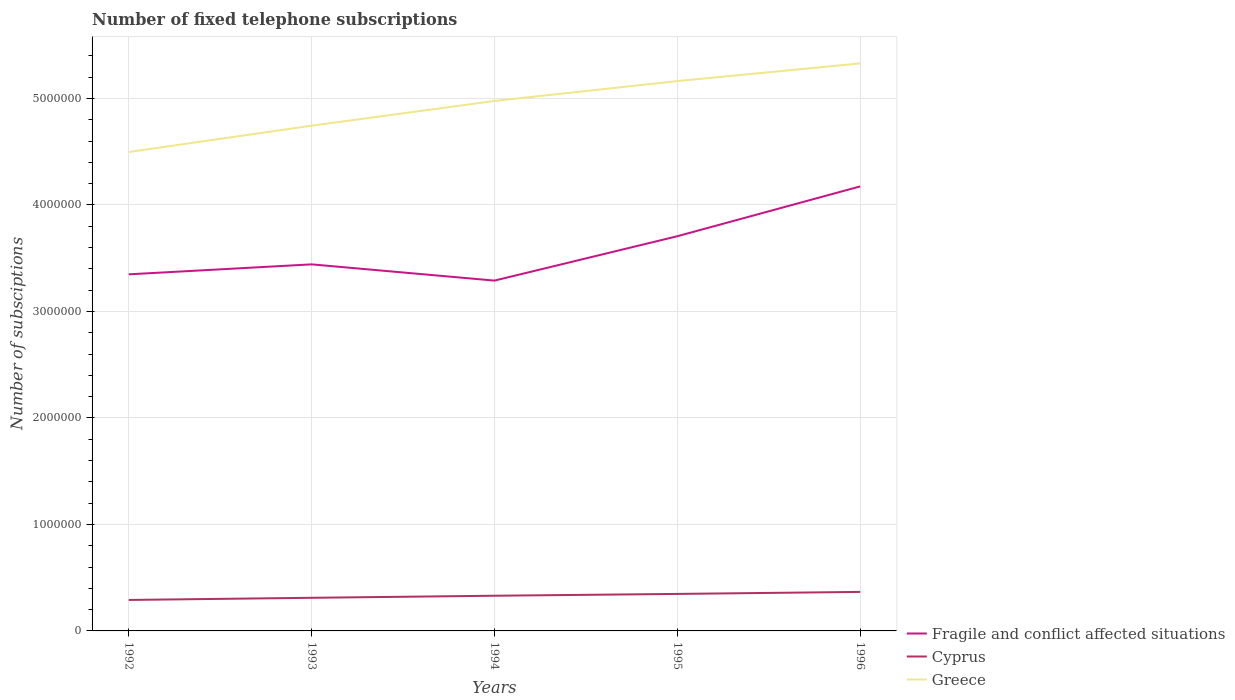How many different coloured lines are there?
Keep it short and to the point. 3. Across all years, what is the maximum number of fixed telephone subscriptions in Greece?
Keep it short and to the point. 4.50e+06. What is the total number of fixed telephone subscriptions in Fragile and conflict affected situations in the graph?
Keep it short and to the point. -9.36e+04. What is the difference between the highest and the second highest number of fixed telephone subscriptions in Cyprus?
Keep it short and to the point. 7.55e+04. Is the number of fixed telephone subscriptions in Fragile and conflict affected situations strictly greater than the number of fixed telephone subscriptions in Cyprus over the years?
Give a very brief answer. No. How many lines are there?
Ensure brevity in your answer.  3. What is the difference between two consecutive major ticks on the Y-axis?
Offer a terse response. 1.00e+06. What is the title of the graph?
Make the answer very short. Number of fixed telephone subscriptions. Does "Burundi" appear as one of the legend labels in the graph?
Offer a terse response. No. What is the label or title of the X-axis?
Provide a short and direct response. Years. What is the label or title of the Y-axis?
Your response must be concise. Number of subsciptions. What is the Number of subsciptions in Fragile and conflict affected situations in 1992?
Your answer should be very brief. 3.35e+06. What is the Number of subsciptions of Cyprus in 1992?
Offer a terse response. 2.91e+05. What is the Number of subsciptions in Greece in 1992?
Give a very brief answer. 4.50e+06. What is the Number of subsciptions in Fragile and conflict affected situations in 1993?
Offer a very short reply. 3.44e+06. What is the Number of subsciptions in Cyprus in 1993?
Make the answer very short. 3.11e+05. What is the Number of subsciptions in Greece in 1993?
Your answer should be compact. 4.74e+06. What is the Number of subsciptions in Fragile and conflict affected situations in 1994?
Make the answer very short. 3.29e+06. What is the Number of subsciptions of Cyprus in 1994?
Make the answer very short. 3.30e+05. What is the Number of subsciptions in Greece in 1994?
Keep it short and to the point. 4.98e+06. What is the Number of subsciptions of Fragile and conflict affected situations in 1995?
Provide a succinct answer. 3.71e+06. What is the Number of subsciptions in Cyprus in 1995?
Keep it short and to the point. 3.47e+05. What is the Number of subsciptions of Greece in 1995?
Give a very brief answer. 5.16e+06. What is the Number of subsciptions in Fragile and conflict affected situations in 1996?
Your answer should be compact. 4.17e+06. What is the Number of subsciptions of Cyprus in 1996?
Give a very brief answer. 3.66e+05. What is the Number of subsciptions of Greece in 1996?
Your response must be concise. 5.33e+06. Across all years, what is the maximum Number of subsciptions in Fragile and conflict affected situations?
Keep it short and to the point. 4.17e+06. Across all years, what is the maximum Number of subsciptions of Cyprus?
Ensure brevity in your answer.  3.66e+05. Across all years, what is the maximum Number of subsciptions in Greece?
Give a very brief answer. 5.33e+06. Across all years, what is the minimum Number of subsciptions of Fragile and conflict affected situations?
Ensure brevity in your answer.  3.29e+06. Across all years, what is the minimum Number of subsciptions in Cyprus?
Provide a short and direct response. 2.91e+05. Across all years, what is the minimum Number of subsciptions of Greece?
Your answer should be compact. 4.50e+06. What is the total Number of subsciptions in Fragile and conflict affected situations in the graph?
Provide a succinct answer. 1.80e+07. What is the total Number of subsciptions in Cyprus in the graph?
Your response must be concise. 1.65e+06. What is the total Number of subsciptions of Greece in the graph?
Your answer should be compact. 2.47e+07. What is the difference between the Number of subsciptions of Fragile and conflict affected situations in 1992 and that in 1993?
Make the answer very short. -9.36e+04. What is the difference between the Number of subsciptions of Cyprus in 1992 and that in 1993?
Offer a very short reply. -2.01e+04. What is the difference between the Number of subsciptions of Greece in 1992 and that in 1993?
Offer a very short reply. -2.47e+05. What is the difference between the Number of subsciptions of Fragile and conflict affected situations in 1992 and that in 1994?
Make the answer very short. 5.88e+04. What is the difference between the Number of subsciptions of Cyprus in 1992 and that in 1994?
Provide a short and direct response. -3.95e+04. What is the difference between the Number of subsciptions of Greece in 1992 and that in 1994?
Your answer should be compact. -4.80e+05. What is the difference between the Number of subsciptions of Fragile and conflict affected situations in 1992 and that in 1995?
Provide a short and direct response. -3.58e+05. What is the difference between the Number of subsciptions of Cyprus in 1992 and that in 1995?
Give a very brief answer. -5.65e+04. What is the difference between the Number of subsciptions in Greece in 1992 and that in 1995?
Provide a succinct answer. -6.66e+05. What is the difference between the Number of subsciptions in Fragile and conflict affected situations in 1992 and that in 1996?
Your response must be concise. -8.26e+05. What is the difference between the Number of subsciptions of Cyprus in 1992 and that in 1996?
Offer a very short reply. -7.55e+04. What is the difference between the Number of subsciptions in Greece in 1992 and that in 1996?
Make the answer very short. -8.32e+05. What is the difference between the Number of subsciptions in Fragile and conflict affected situations in 1993 and that in 1994?
Keep it short and to the point. 1.52e+05. What is the difference between the Number of subsciptions in Cyprus in 1993 and that in 1994?
Provide a short and direct response. -1.94e+04. What is the difference between the Number of subsciptions of Greece in 1993 and that in 1994?
Your answer should be very brief. -2.32e+05. What is the difference between the Number of subsciptions in Fragile and conflict affected situations in 1993 and that in 1995?
Make the answer very short. -2.64e+05. What is the difference between the Number of subsciptions in Cyprus in 1993 and that in 1995?
Give a very brief answer. -3.64e+04. What is the difference between the Number of subsciptions of Greece in 1993 and that in 1995?
Ensure brevity in your answer.  -4.19e+05. What is the difference between the Number of subsciptions in Fragile and conflict affected situations in 1993 and that in 1996?
Provide a succinct answer. -7.32e+05. What is the difference between the Number of subsciptions in Cyprus in 1993 and that in 1996?
Your answer should be very brief. -5.54e+04. What is the difference between the Number of subsciptions of Greece in 1993 and that in 1996?
Give a very brief answer. -5.85e+05. What is the difference between the Number of subsciptions in Fragile and conflict affected situations in 1994 and that in 1995?
Provide a short and direct response. -4.17e+05. What is the difference between the Number of subsciptions of Cyprus in 1994 and that in 1995?
Ensure brevity in your answer.  -1.70e+04. What is the difference between the Number of subsciptions of Greece in 1994 and that in 1995?
Keep it short and to the point. -1.87e+05. What is the difference between the Number of subsciptions of Fragile and conflict affected situations in 1994 and that in 1996?
Give a very brief answer. -8.85e+05. What is the difference between the Number of subsciptions of Cyprus in 1994 and that in 1996?
Offer a very short reply. -3.60e+04. What is the difference between the Number of subsciptions in Greece in 1994 and that in 1996?
Provide a short and direct response. -3.53e+05. What is the difference between the Number of subsciptions in Fragile and conflict affected situations in 1995 and that in 1996?
Ensure brevity in your answer.  -4.68e+05. What is the difference between the Number of subsciptions in Cyprus in 1995 and that in 1996?
Your answer should be compact. -1.90e+04. What is the difference between the Number of subsciptions of Greece in 1995 and that in 1996?
Give a very brief answer. -1.66e+05. What is the difference between the Number of subsciptions of Fragile and conflict affected situations in 1992 and the Number of subsciptions of Cyprus in 1993?
Provide a succinct answer. 3.04e+06. What is the difference between the Number of subsciptions of Fragile and conflict affected situations in 1992 and the Number of subsciptions of Greece in 1993?
Offer a terse response. -1.40e+06. What is the difference between the Number of subsciptions of Cyprus in 1992 and the Number of subsciptions of Greece in 1993?
Offer a very short reply. -4.45e+06. What is the difference between the Number of subsciptions in Fragile and conflict affected situations in 1992 and the Number of subsciptions in Cyprus in 1994?
Ensure brevity in your answer.  3.02e+06. What is the difference between the Number of subsciptions in Fragile and conflict affected situations in 1992 and the Number of subsciptions in Greece in 1994?
Provide a short and direct response. -1.63e+06. What is the difference between the Number of subsciptions of Cyprus in 1992 and the Number of subsciptions of Greece in 1994?
Your response must be concise. -4.69e+06. What is the difference between the Number of subsciptions of Fragile and conflict affected situations in 1992 and the Number of subsciptions of Cyprus in 1995?
Give a very brief answer. 3.00e+06. What is the difference between the Number of subsciptions of Fragile and conflict affected situations in 1992 and the Number of subsciptions of Greece in 1995?
Offer a very short reply. -1.81e+06. What is the difference between the Number of subsciptions in Cyprus in 1992 and the Number of subsciptions in Greece in 1995?
Provide a succinct answer. -4.87e+06. What is the difference between the Number of subsciptions in Fragile and conflict affected situations in 1992 and the Number of subsciptions in Cyprus in 1996?
Give a very brief answer. 2.98e+06. What is the difference between the Number of subsciptions of Fragile and conflict affected situations in 1992 and the Number of subsciptions of Greece in 1996?
Give a very brief answer. -1.98e+06. What is the difference between the Number of subsciptions in Cyprus in 1992 and the Number of subsciptions in Greece in 1996?
Provide a succinct answer. -5.04e+06. What is the difference between the Number of subsciptions in Fragile and conflict affected situations in 1993 and the Number of subsciptions in Cyprus in 1994?
Your response must be concise. 3.11e+06. What is the difference between the Number of subsciptions of Fragile and conflict affected situations in 1993 and the Number of subsciptions of Greece in 1994?
Make the answer very short. -1.53e+06. What is the difference between the Number of subsciptions in Cyprus in 1993 and the Number of subsciptions in Greece in 1994?
Offer a terse response. -4.67e+06. What is the difference between the Number of subsciptions in Fragile and conflict affected situations in 1993 and the Number of subsciptions in Cyprus in 1995?
Ensure brevity in your answer.  3.09e+06. What is the difference between the Number of subsciptions of Fragile and conflict affected situations in 1993 and the Number of subsciptions of Greece in 1995?
Your answer should be very brief. -1.72e+06. What is the difference between the Number of subsciptions in Cyprus in 1993 and the Number of subsciptions in Greece in 1995?
Your answer should be very brief. -4.85e+06. What is the difference between the Number of subsciptions of Fragile and conflict affected situations in 1993 and the Number of subsciptions of Cyprus in 1996?
Your answer should be compact. 3.08e+06. What is the difference between the Number of subsciptions of Fragile and conflict affected situations in 1993 and the Number of subsciptions of Greece in 1996?
Ensure brevity in your answer.  -1.89e+06. What is the difference between the Number of subsciptions in Cyprus in 1993 and the Number of subsciptions in Greece in 1996?
Ensure brevity in your answer.  -5.02e+06. What is the difference between the Number of subsciptions in Fragile and conflict affected situations in 1994 and the Number of subsciptions in Cyprus in 1995?
Make the answer very short. 2.94e+06. What is the difference between the Number of subsciptions of Fragile and conflict affected situations in 1994 and the Number of subsciptions of Greece in 1995?
Your answer should be compact. -1.87e+06. What is the difference between the Number of subsciptions of Cyprus in 1994 and the Number of subsciptions of Greece in 1995?
Your answer should be compact. -4.83e+06. What is the difference between the Number of subsciptions of Fragile and conflict affected situations in 1994 and the Number of subsciptions of Cyprus in 1996?
Give a very brief answer. 2.92e+06. What is the difference between the Number of subsciptions in Fragile and conflict affected situations in 1994 and the Number of subsciptions in Greece in 1996?
Give a very brief answer. -2.04e+06. What is the difference between the Number of subsciptions of Cyprus in 1994 and the Number of subsciptions of Greece in 1996?
Give a very brief answer. -5.00e+06. What is the difference between the Number of subsciptions in Fragile and conflict affected situations in 1995 and the Number of subsciptions in Cyprus in 1996?
Make the answer very short. 3.34e+06. What is the difference between the Number of subsciptions in Fragile and conflict affected situations in 1995 and the Number of subsciptions in Greece in 1996?
Ensure brevity in your answer.  -1.62e+06. What is the difference between the Number of subsciptions in Cyprus in 1995 and the Number of subsciptions in Greece in 1996?
Offer a very short reply. -4.98e+06. What is the average Number of subsciptions of Fragile and conflict affected situations per year?
Offer a very short reply. 3.59e+06. What is the average Number of subsciptions of Cyprus per year?
Offer a terse response. 3.29e+05. What is the average Number of subsciptions of Greece per year?
Offer a terse response. 4.94e+06. In the year 1992, what is the difference between the Number of subsciptions in Fragile and conflict affected situations and Number of subsciptions in Cyprus?
Ensure brevity in your answer.  3.06e+06. In the year 1992, what is the difference between the Number of subsciptions of Fragile and conflict affected situations and Number of subsciptions of Greece?
Ensure brevity in your answer.  -1.15e+06. In the year 1992, what is the difference between the Number of subsciptions of Cyprus and Number of subsciptions of Greece?
Offer a terse response. -4.21e+06. In the year 1993, what is the difference between the Number of subsciptions in Fragile and conflict affected situations and Number of subsciptions in Cyprus?
Provide a succinct answer. 3.13e+06. In the year 1993, what is the difference between the Number of subsciptions in Fragile and conflict affected situations and Number of subsciptions in Greece?
Offer a terse response. -1.30e+06. In the year 1993, what is the difference between the Number of subsciptions in Cyprus and Number of subsciptions in Greece?
Provide a succinct answer. -4.43e+06. In the year 1994, what is the difference between the Number of subsciptions in Fragile and conflict affected situations and Number of subsciptions in Cyprus?
Make the answer very short. 2.96e+06. In the year 1994, what is the difference between the Number of subsciptions of Fragile and conflict affected situations and Number of subsciptions of Greece?
Your answer should be very brief. -1.69e+06. In the year 1994, what is the difference between the Number of subsciptions in Cyprus and Number of subsciptions in Greece?
Offer a very short reply. -4.65e+06. In the year 1995, what is the difference between the Number of subsciptions in Fragile and conflict affected situations and Number of subsciptions in Cyprus?
Offer a terse response. 3.36e+06. In the year 1995, what is the difference between the Number of subsciptions of Fragile and conflict affected situations and Number of subsciptions of Greece?
Ensure brevity in your answer.  -1.46e+06. In the year 1995, what is the difference between the Number of subsciptions in Cyprus and Number of subsciptions in Greece?
Provide a succinct answer. -4.82e+06. In the year 1996, what is the difference between the Number of subsciptions in Fragile and conflict affected situations and Number of subsciptions in Cyprus?
Provide a succinct answer. 3.81e+06. In the year 1996, what is the difference between the Number of subsciptions in Fragile and conflict affected situations and Number of subsciptions in Greece?
Your answer should be compact. -1.15e+06. In the year 1996, what is the difference between the Number of subsciptions in Cyprus and Number of subsciptions in Greece?
Provide a succinct answer. -4.96e+06. What is the ratio of the Number of subsciptions in Fragile and conflict affected situations in 1992 to that in 1993?
Offer a terse response. 0.97. What is the ratio of the Number of subsciptions in Cyprus in 1992 to that in 1993?
Provide a succinct answer. 0.94. What is the ratio of the Number of subsciptions of Greece in 1992 to that in 1993?
Make the answer very short. 0.95. What is the ratio of the Number of subsciptions of Fragile and conflict affected situations in 1992 to that in 1994?
Your answer should be very brief. 1.02. What is the ratio of the Number of subsciptions in Cyprus in 1992 to that in 1994?
Make the answer very short. 0.88. What is the ratio of the Number of subsciptions of Greece in 1992 to that in 1994?
Offer a terse response. 0.9. What is the ratio of the Number of subsciptions in Fragile and conflict affected situations in 1992 to that in 1995?
Keep it short and to the point. 0.9. What is the ratio of the Number of subsciptions of Cyprus in 1992 to that in 1995?
Your answer should be compact. 0.84. What is the ratio of the Number of subsciptions in Greece in 1992 to that in 1995?
Your response must be concise. 0.87. What is the ratio of the Number of subsciptions of Fragile and conflict affected situations in 1992 to that in 1996?
Your answer should be compact. 0.8. What is the ratio of the Number of subsciptions of Cyprus in 1992 to that in 1996?
Provide a short and direct response. 0.79. What is the ratio of the Number of subsciptions of Greece in 1992 to that in 1996?
Your answer should be very brief. 0.84. What is the ratio of the Number of subsciptions of Fragile and conflict affected situations in 1993 to that in 1994?
Your answer should be compact. 1.05. What is the ratio of the Number of subsciptions of Cyprus in 1993 to that in 1994?
Offer a terse response. 0.94. What is the ratio of the Number of subsciptions in Greece in 1993 to that in 1994?
Keep it short and to the point. 0.95. What is the ratio of the Number of subsciptions in Fragile and conflict affected situations in 1993 to that in 1995?
Provide a succinct answer. 0.93. What is the ratio of the Number of subsciptions of Cyprus in 1993 to that in 1995?
Provide a succinct answer. 0.9. What is the ratio of the Number of subsciptions in Greece in 1993 to that in 1995?
Make the answer very short. 0.92. What is the ratio of the Number of subsciptions of Fragile and conflict affected situations in 1993 to that in 1996?
Offer a very short reply. 0.82. What is the ratio of the Number of subsciptions of Cyprus in 1993 to that in 1996?
Offer a very short reply. 0.85. What is the ratio of the Number of subsciptions of Greece in 1993 to that in 1996?
Offer a very short reply. 0.89. What is the ratio of the Number of subsciptions of Fragile and conflict affected situations in 1994 to that in 1995?
Give a very brief answer. 0.89. What is the ratio of the Number of subsciptions in Cyprus in 1994 to that in 1995?
Your response must be concise. 0.95. What is the ratio of the Number of subsciptions of Greece in 1994 to that in 1995?
Offer a terse response. 0.96. What is the ratio of the Number of subsciptions in Fragile and conflict affected situations in 1994 to that in 1996?
Give a very brief answer. 0.79. What is the ratio of the Number of subsciptions of Cyprus in 1994 to that in 1996?
Provide a succinct answer. 0.9. What is the ratio of the Number of subsciptions of Greece in 1994 to that in 1996?
Make the answer very short. 0.93. What is the ratio of the Number of subsciptions in Fragile and conflict affected situations in 1995 to that in 1996?
Offer a terse response. 0.89. What is the ratio of the Number of subsciptions in Cyprus in 1995 to that in 1996?
Your answer should be compact. 0.95. What is the ratio of the Number of subsciptions of Greece in 1995 to that in 1996?
Ensure brevity in your answer.  0.97. What is the difference between the highest and the second highest Number of subsciptions in Fragile and conflict affected situations?
Offer a very short reply. 4.68e+05. What is the difference between the highest and the second highest Number of subsciptions in Cyprus?
Provide a short and direct response. 1.90e+04. What is the difference between the highest and the second highest Number of subsciptions in Greece?
Offer a very short reply. 1.66e+05. What is the difference between the highest and the lowest Number of subsciptions in Fragile and conflict affected situations?
Your answer should be very brief. 8.85e+05. What is the difference between the highest and the lowest Number of subsciptions of Cyprus?
Keep it short and to the point. 7.55e+04. What is the difference between the highest and the lowest Number of subsciptions in Greece?
Provide a short and direct response. 8.32e+05. 